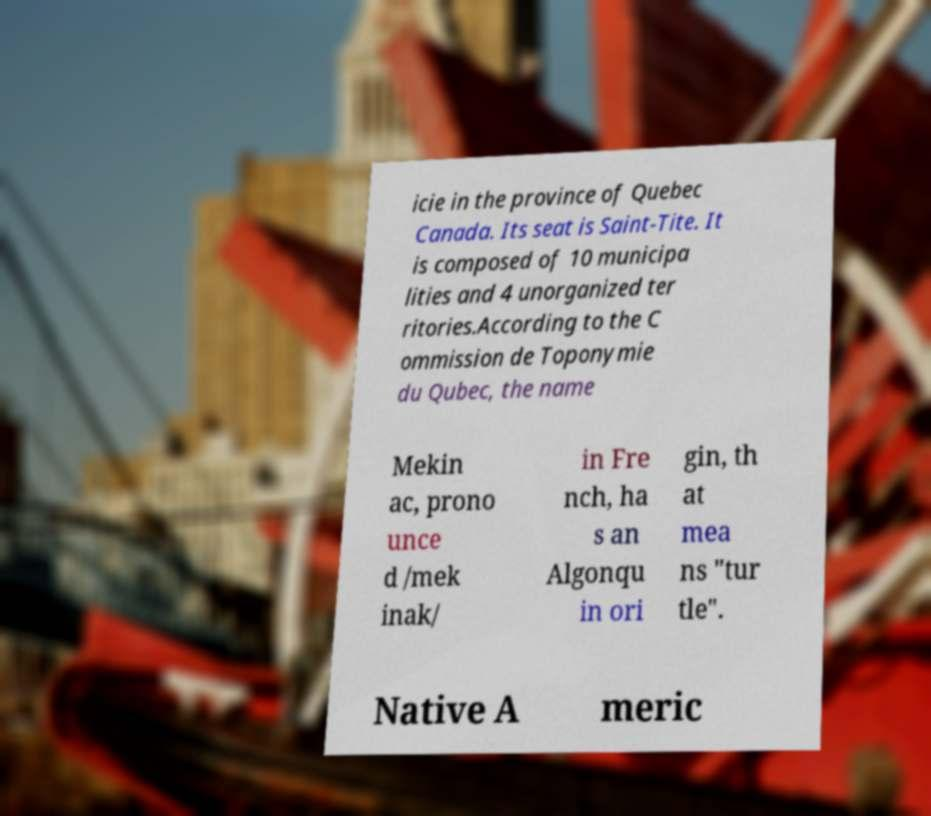What messages or text are displayed in this image? I need them in a readable, typed format. icie in the province of Quebec Canada. Its seat is Saint-Tite. It is composed of 10 municipa lities and 4 unorganized ter ritories.According to the C ommission de Toponymie du Qubec, the name Mekin ac, prono unce d /mek inak/ in Fre nch, ha s an Algonqu in ori gin, th at mea ns "tur tle". Native A meric 